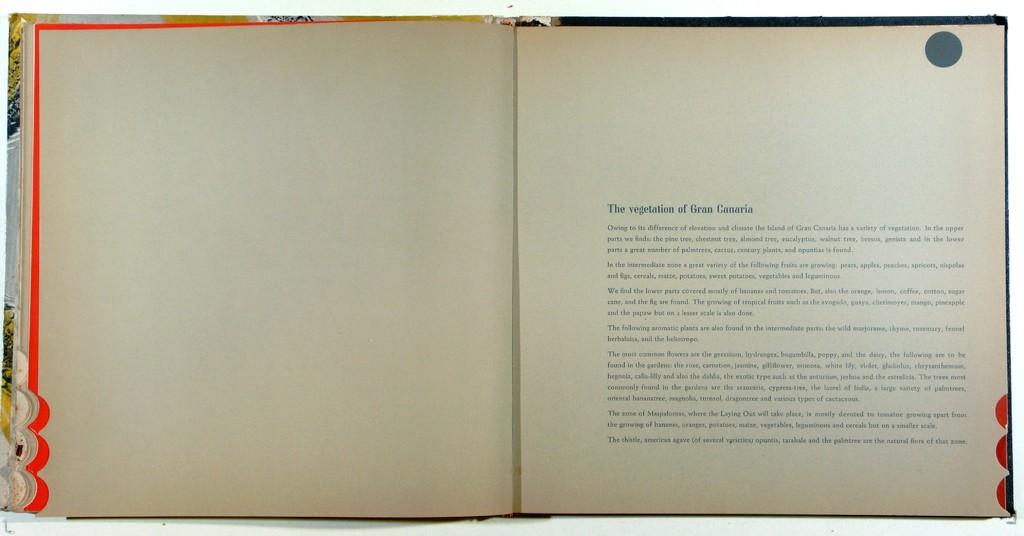What is the first word after the title?
Your answer should be very brief. Owing. 